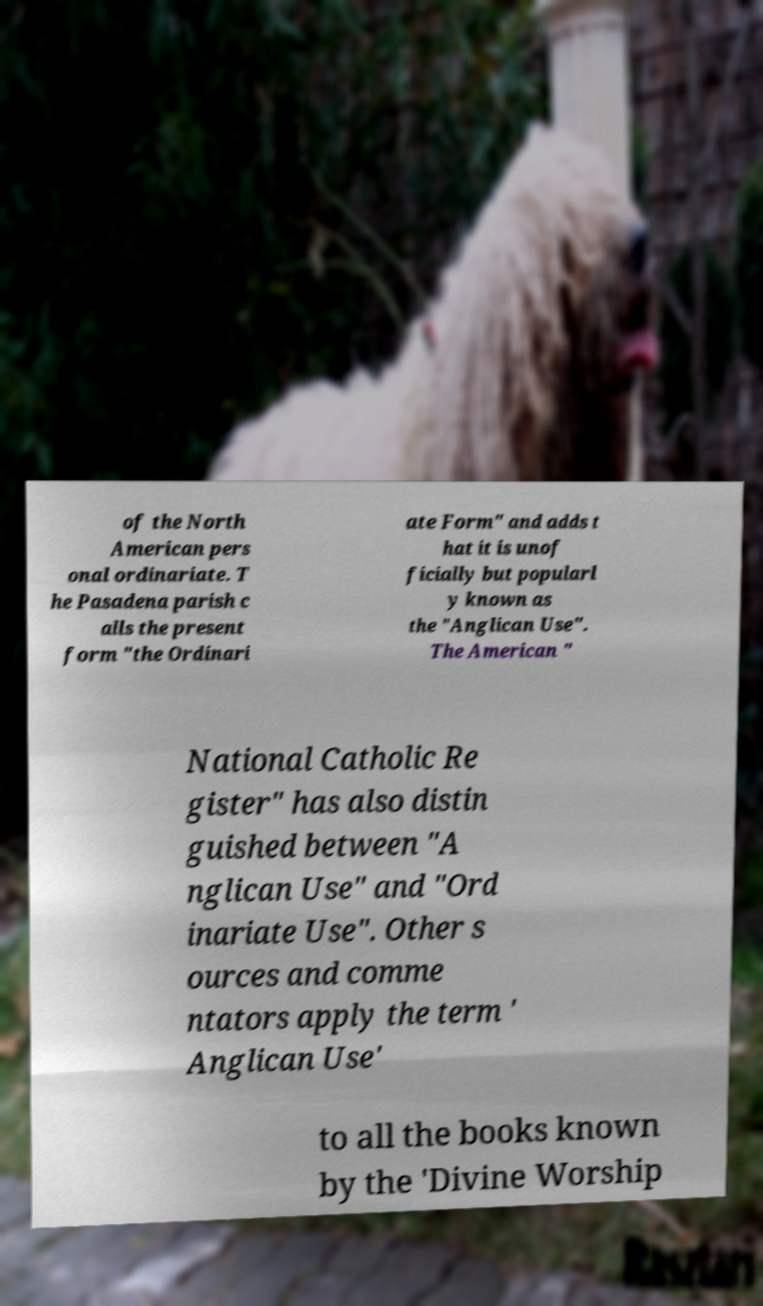Could you extract and type out the text from this image? of the North American pers onal ordinariate. T he Pasadena parish c alls the present form "the Ordinari ate Form" and adds t hat it is unof ficially but popularl y known as the "Anglican Use". The American " National Catholic Re gister" has also distin guished between "A nglican Use" and "Ord inariate Use". Other s ources and comme ntators apply the term ' Anglican Use' to all the books known by the 'Divine Worship 